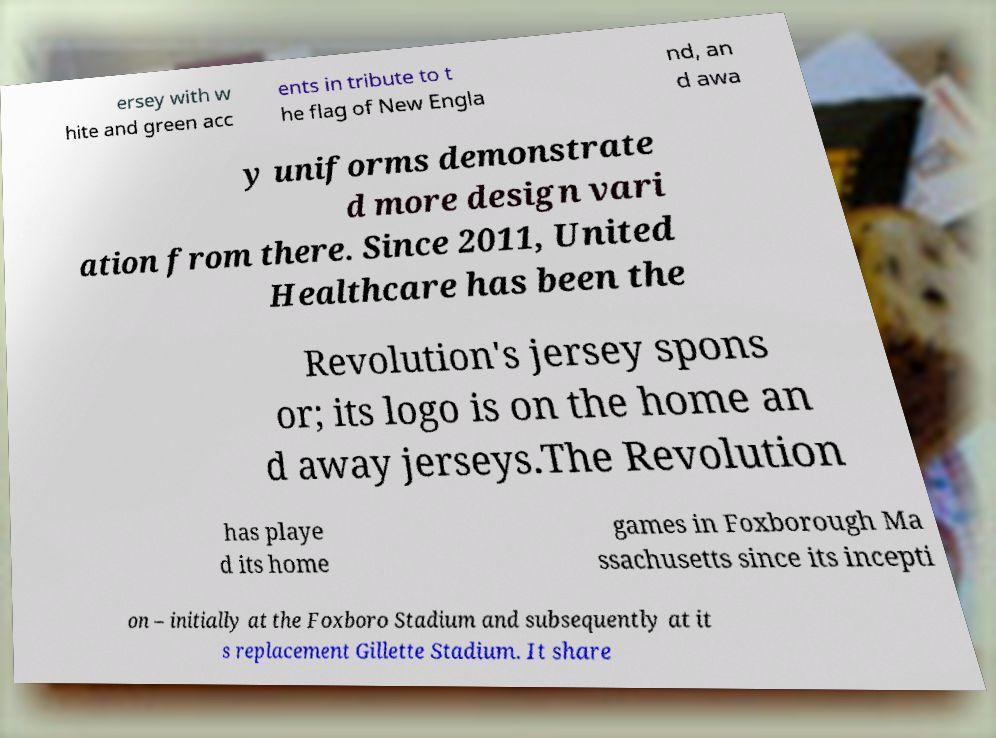Could you extract and type out the text from this image? ersey with w hite and green acc ents in tribute to t he flag of New Engla nd, an d awa y uniforms demonstrate d more design vari ation from there. Since 2011, United Healthcare has been the Revolution's jersey spons or; its logo is on the home an d away jerseys.The Revolution has playe d its home games in Foxborough Ma ssachusetts since its incepti on – initially at the Foxboro Stadium and subsequently at it s replacement Gillette Stadium. It share 